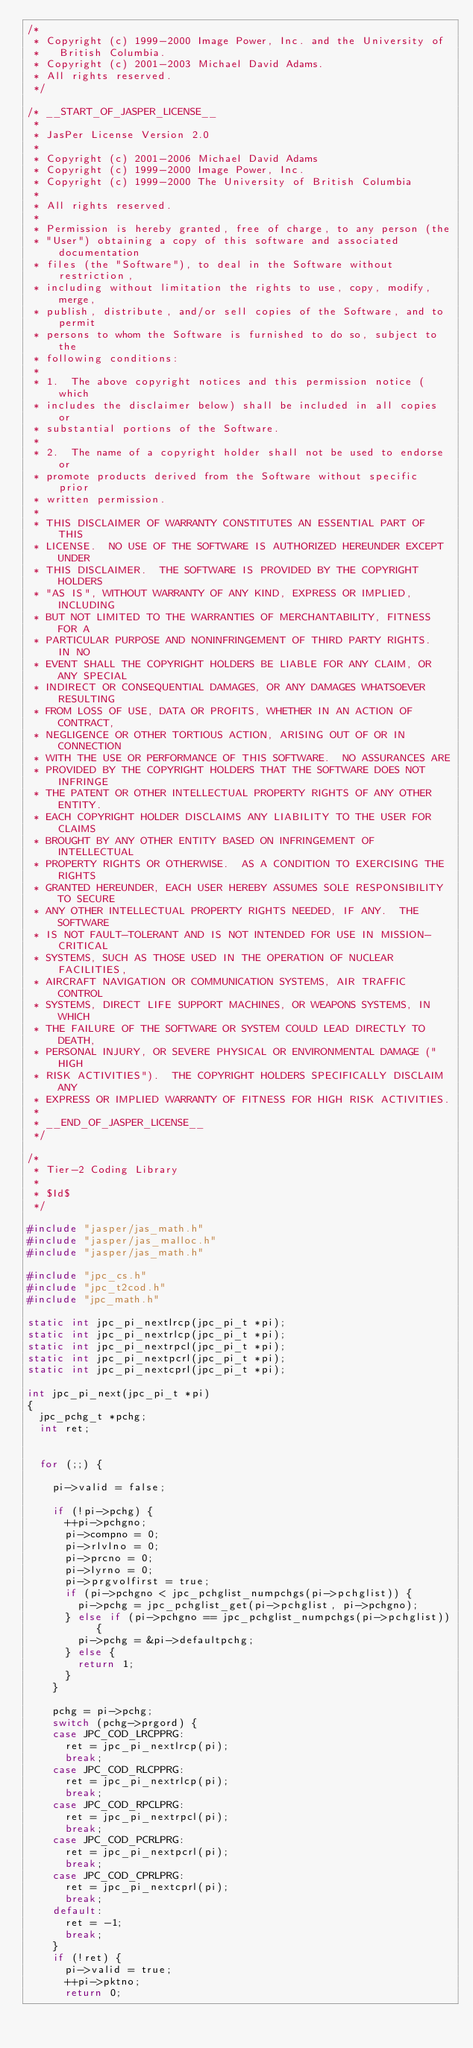Convert code to text. <code><loc_0><loc_0><loc_500><loc_500><_C_>/*
 * Copyright (c) 1999-2000 Image Power, Inc. and the University of
 *   British Columbia.
 * Copyright (c) 2001-2003 Michael David Adams.
 * All rights reserved.
 */

/* __START_OF_JASPER_LICENSE__
 * 
 * JasPer License Version 2.0
 * 
 * Copyright (c) 2001-2006 Michael David Adams
 * Copyright (c) 1999-2000 Image Power, Inc.
 * Copyright (c) 1999-2000 The University of British Columbia
 * 
 * All rights reserved.
 * 
 * Permission is hereby granted, free of charge, to any person (the
 * "User") obtaining a copy of this software and associated documentation
 * files (the "Software"), to deal in the Software without restriction,
 * including without limitation the rights to use, copy, modify, merge,
 * publish, distribute, and/or sell copies of the Software, and to permit
 * persons to whom the Software is furnished to do so, subject to the
 * following conditions:
 * 
 * 1.  The above copyright notices and this permission notice (which
 * includes the disclaimer below) shall be included in all copies or
 * substantial portions of the Software.
 * 
 * 2.  The name of a copyright holder shall not be used to endorse or
 * promote products derived from the Software without specific prior
 * written permission.
 * 
 * THIS DISCLAIMER OF WARRANTY CONSTITUTES AN ESSENTIAL PART OF THIS
 * LICENSE.  NO USE OF THE SOFTWARE IS AUTHORIZED HEREUNDER EXCEPT UNDER
 * THIS DISCLAIMER.  THE SOFTWARE IS PROVIDED BY THE COPYRIGHT HOLDERS
 * "AS IS", WITHOUT WARRANTY OF ANY KIND, EXPRESS OR IMPLIED, INCLUDING
 * BUT NOT LIMITED TO THE WARRANTIES OF MERCHANTABILITY, FITNESS FOR A
 * PARTICULAR PURPOSE AND NONINFRINGEMENT OF THIRD PARTY RIGHTS.  IN NO
 * EVENT SHALL THE COPYRIGHT HOLDERS BE LIABLE FOR ANY CLAIM, OR ANY SPECIAL
 * INDIRECT OR CONSEQUENTIAL DAMAGES, OR ANY DAMAGES WHATSOEVER RESULTING
 * FROM LOSS OF USE, DATA OR PROFITS, WHETHER IN AN ACTION OF CONTRACT,
 * NEGLIGENCE OR OTHER TORTIOUS ACTION, ARISING OUT OF OR IN CONNECTION
 * WITH THE USE OR PERFORMANCE OF THIS SOFTWARE.  NO ASSURANCES ARE
 * PROVIDED BY THE COPYRIGHT HOLDERS THAT THE SOFTWARE DOES NOT INFRINGE
 * THE PATENT OR OTHER INTELLECTUAL PROPERTY RIGHTS OF ANY OTHER ENTITY.
 * EACH COPYRIGHT HOLDER DISCLAIMS ANY LIABILITY TO THE USER FOR CLAIMS
 * BROUGHT BY ANY OTHER ENTITY BASED ON INFRINGEMENT OF INTELLECTUAL
 * PROPERTY RIGHTS OR OTHERWISE.  AS A CONDITION TO EXERCISING THE RIGHTS
 * GRANTED HEREUNDER, EACH USER HEREBY ASSUMES SOLE RESPONSIBILITY TO SECURE
 * ANY OTHER INTELLECTUAL PROPERTY RIGHTS NEEDED, IF ANY.  THE SOFTWARE
 * IS NOT FAULT-TOLERANT AND IS NOT INTENDED FOR USE IN MISSION-CRITICAL
 * SYSTEMS, SUCH AS THOSE USED IN THE OPERATION OF NUCLEAR FACILITIES,
 * AIRCRAFT NAVIGATION OR COMMUNICATION SYSTEMS, AIR TRAFFIC CONTROL
 * SYSTEMS, DIRECT LIFE SUPPORT MACHINES, OR WEAPONS SYSTEMS, IN WHICH
 * THE FAILURE OF THE SOFTWARE OR SYSTEM COULD LEAD DIRECTLY TO DEATH,
 * PERSONAL INJURY, OR SEVERE PHYSICAL OR ENVIRONMENTAL DAMAGE ("HIGH
 * RISK ACTIVITIES").  THE COPYRIGHT HOLDERS SPECIFICALLY DISCLAIM ANY
 * EXPRESS OR IMPLIED WARRANTY OF FITNESS FOR HIGH RISK ACTIVITIES.
 * 
 * __END_OF_JASPER_LICENSE__
 */

/*
 * Tier-2 Coding Library
 *
 * $Id$
 */

#include "jasper/jas_math.h"
#include "jasper/jas_malloc.h"
#include "jasper/jas_math.h"

#include "jpc_cs.h"
#include "jpc_t2cod.h"
#include "jpc_math.h"

static int jpc_pi_nextlrcp(jpc_pi_t *pi);
static int jpc_pi_nextrlcp(jpc_pi_t *pi);
static int jpc_pi_nextrpcl(jpc_pi_t *pi);
static int jpc_pi_nextpcrl(jpc_pi_t *pi);
static int jpc_pi_nextcprl(jpc_pi_t *pi);

int jpc_pi_next(jpc_pi_t *pi)
{
	jpc_pchg_t *pchg;
	int ret;


	for (;;) {

		pi->valid = false;

		if (!pi->pchg) {
			++pi->pchgno;
			pi->compno = 0;
			pi->rlvlno = 0;
			pi->prcno = 0;
			pi->lyrno = 0;
			pi->prgvolfirst = true;
			if (pi->pchgno < jpc_pchglist_numpchgs(pi->pchglist)) {
				pi->pchg = jpc_pchglist_get(pi->pchglist, pi->pchgno);
			} else if (pi->pchgno == jpc_pchglist_numpchgs(pi->pchglist)) {
				pi->pchg = &pi->defaultpchg;
			} else {
				return 1;
			}
		}

		pchg = pi->pchg;
		switch (pchg->prgord) {
		case JPC_COD_LRCPPRG:
			ret = jpc_pi_nextlrcp(pi);
			break;
		case JPC_COD_RLCPPRG:
			ret = jpc_pi_nextrlcp(pi);
			break;
		case JPC_COD_RPCLPRG:
			ret = jpc_pi_nextrpcl(pi);
			break;
		case JPC_COD_PCRLPRG:
			ret = jpc_pi_nextpcrl(pi);
			break;
		case JPC_COD_CPRLPRG:
			ret = jpc_pi_nextcprl(pi);
			break;
		default:
			ret = -1;
			break;
		}
		if (!ret) {
			pi->valid = true;
			++pi->pktno;
			return 0;</code> 